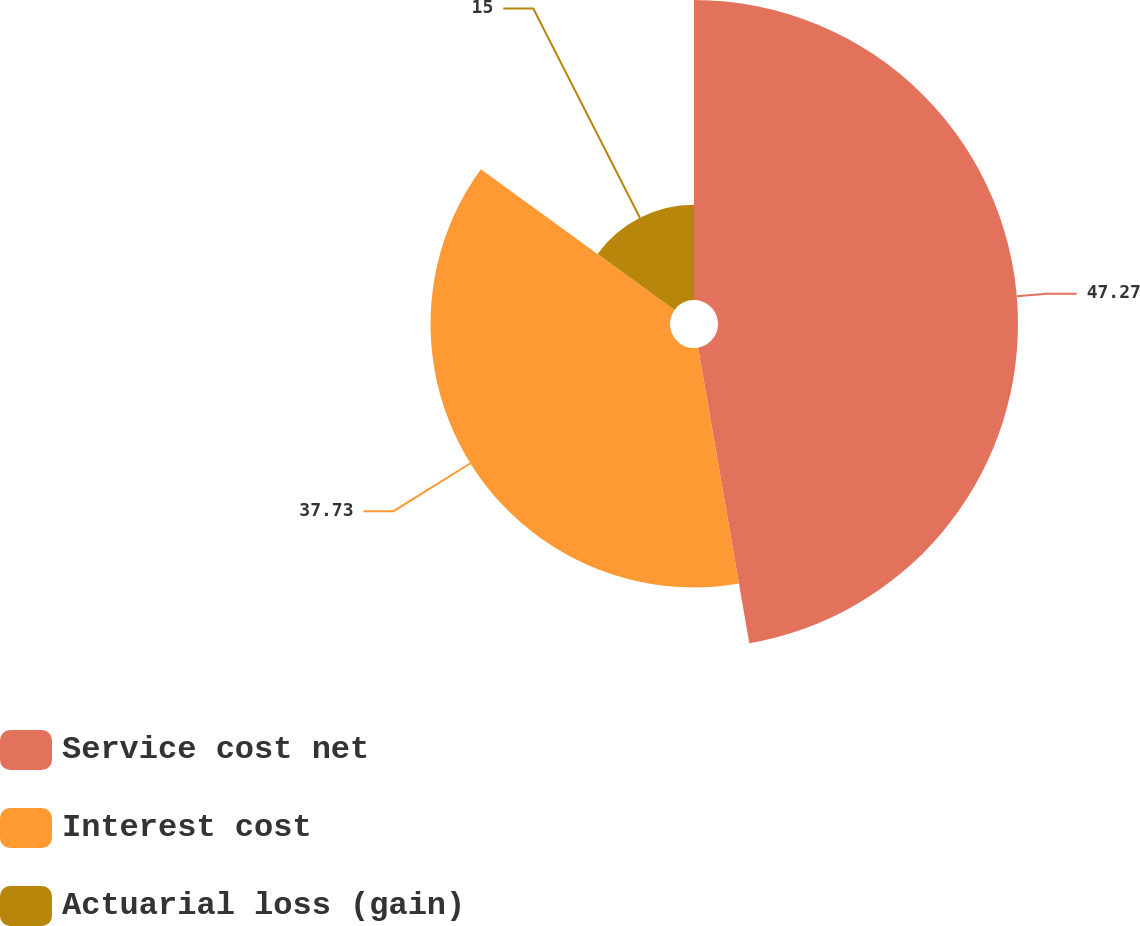Convert chart. <chart><loc_0><loc_0><loc_500><loc_500><pie_chart><fcel>Service cost net<fcel>Interest cost<fcel>Actuarial loss (gain)<nl><fcel>47.27%<fcel>37.73%<fcel>15.0%<nl></chart> 